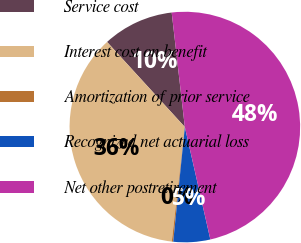Convert chart. <chart><loc_0><loc_0><loc_500><loc_500><pie_chart><fcel>Service cost<fcel>Interest cost on benefit<fcel>Amortization of prior service<fcel>Recognized net actuarial loss<fcel>Net other postretirement<nl><fcel>9.97%<fcel>36.4%<fcel>0.2%<fcel>5.16%<fcel>48.27%<nl></chart> 